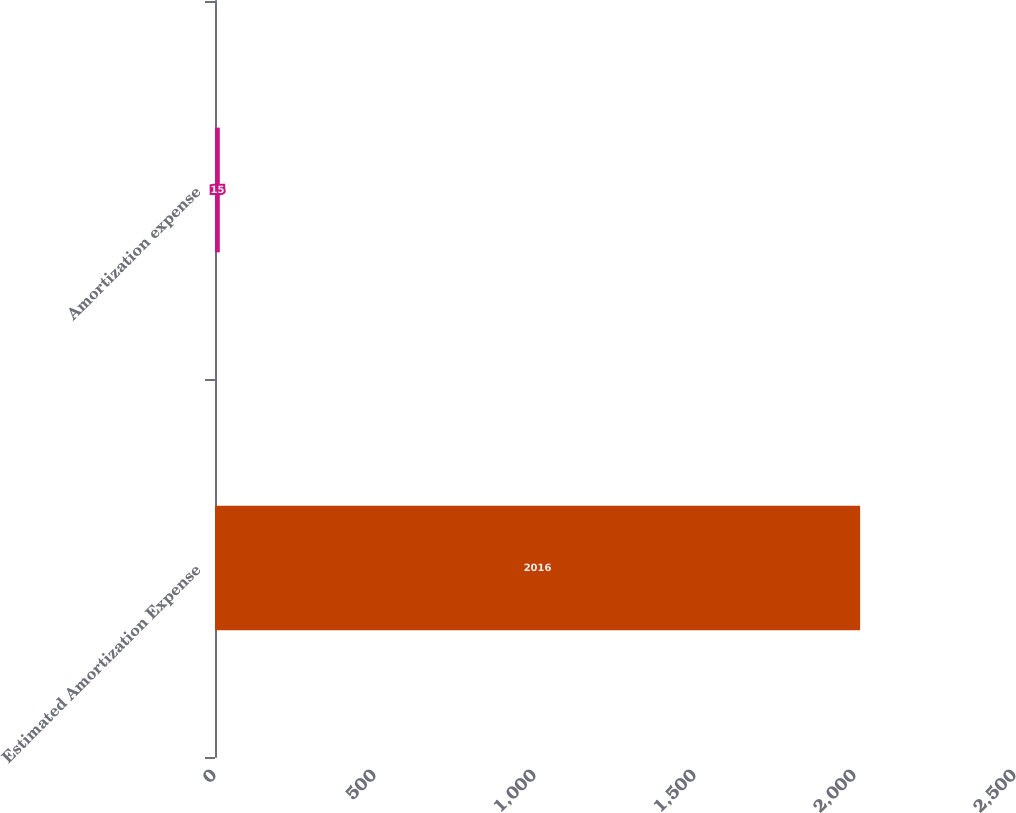<chart> <loc_0><loc_0><loc_500><loc_500><bar_chart><fcel>Estimated Amortization Expense<fcel>Amortization expense<nl><fcel>2016<fcel>15<nl></chart> 